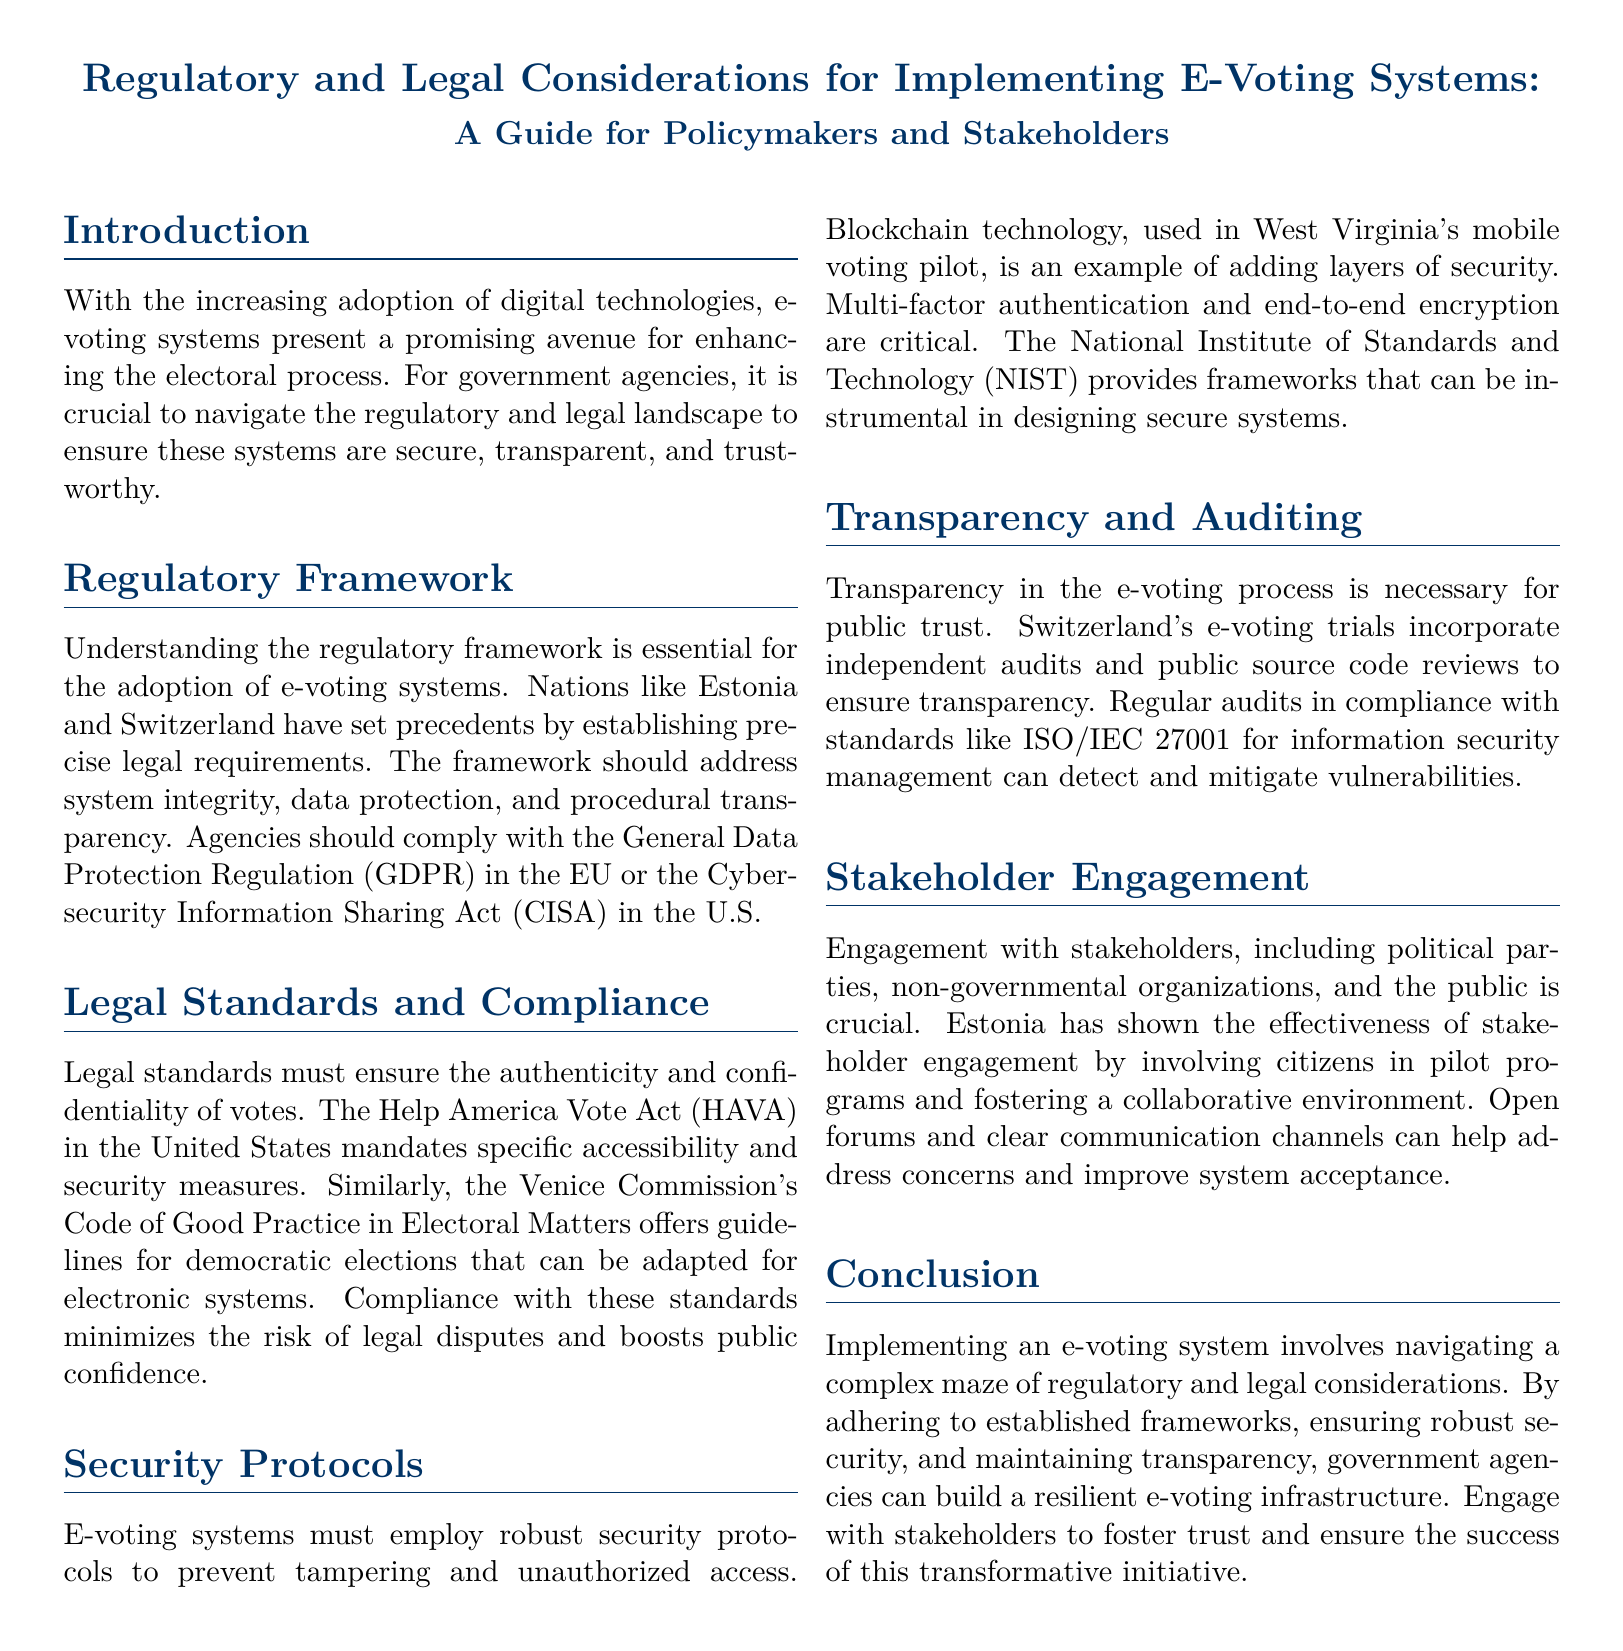What is the title of the document? The title is prominently displayed at the beginning of the document, highlighting its focus on regulatory and legal considerations in e-voting systems.
Answer: Regulatory and Legal Considerations for Implementing E-Voting Systems: A Guide for Policymakers and Stakeholders Which act mandates specific accessibility and security measures in the U.S.? The document references legal standards that ensure voting security, highlighting the Help America Vote Act as a key legislative framework.
Answer: Help America Vote Act (HAVA) What technology is mentioned as a security measure in e-voting? Blockchain technology is specifically cited as an example of a security measure used in mobile voting, illustrating advanced security options.
Answer: Blockchain What standard is recommended for information security management? The document notes that ISO/IEC 27001 is a relevant standard for conducting regular audits to enhance information security in e-voting systems.
Answer: ISO/IEC 27001 How has Estonia fostered stakeholder engagement? Estonia's approach to stakeholder engagement included involving citizens in pilot programs, demonstrating a model for effective public participation.
Answer: Involving citizens in pilot programs What is a critical element for maintaining public trust in the e-voting process? The document emphasizes that transparency is essential for public trust, underscoring the importance of open practices in e-voting.
Answer: Transparency What does GDPR stand for? The document mentions the General Data Protection Regulation as an important regulatory compliance requirement for e-voting systems in the EU context.
Answer: General Data Protection Regulation What are the main components the regulatory framework should address? The document specifies that system integrity, data protection, and procedural transparency should be key focus areas of the regulatory framework.
Answer: System integrity, data protection, procedural transparency 